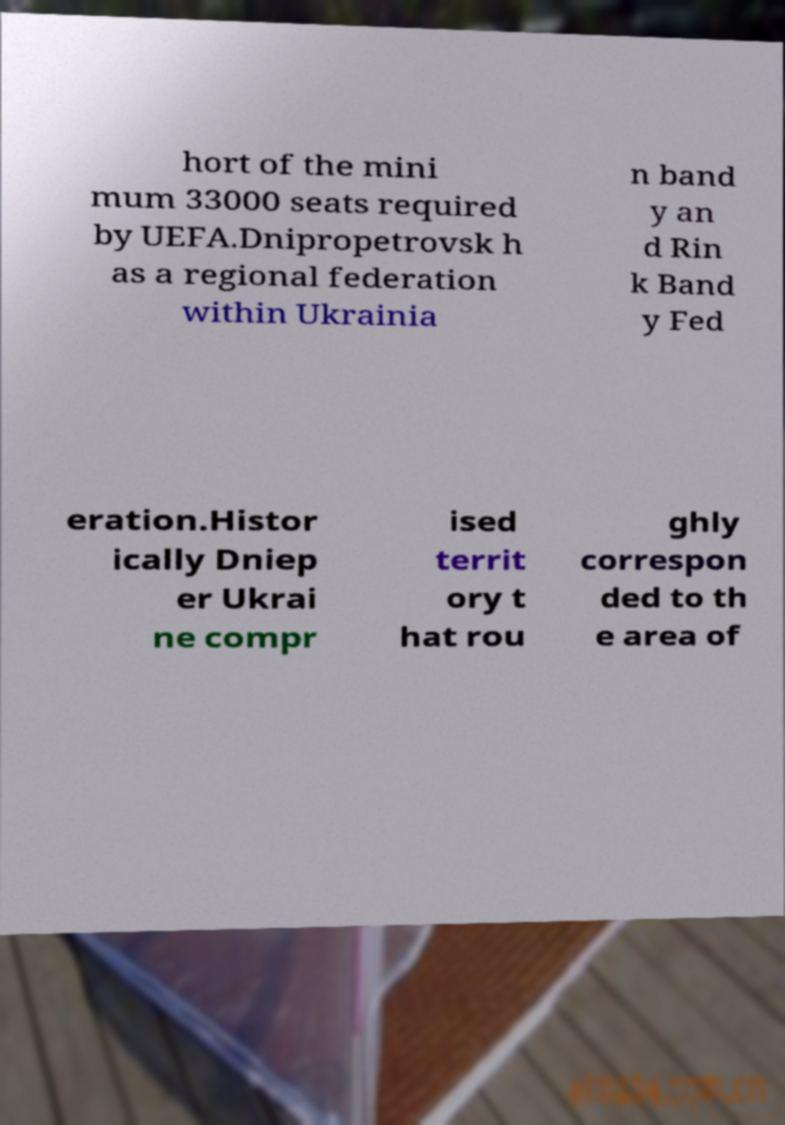What messages or text are displayed in this image? I need them in a readable, typed format. hort of the mini mum 33000 seats required by UEFA.Dnipropetrovsk h as a regional federation within Ukrainia n band y an d Rin k Band y Fed eration.Histor ically Dniep er Ukrai ne compr ised territ ory t hat rou ghly correspon ded to th e area of 